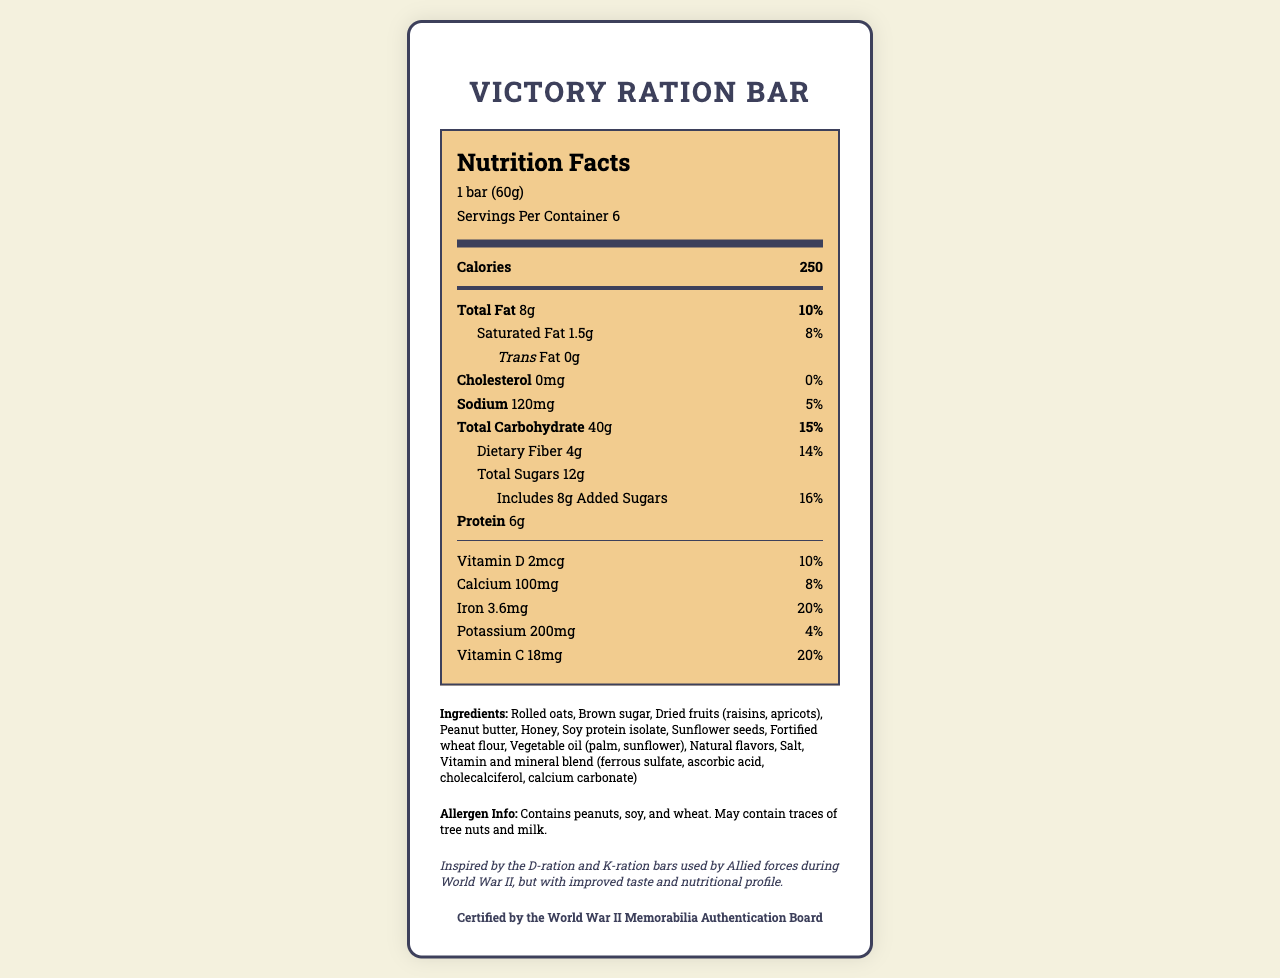what is the serving size for the Victory Ration Bar? The serving size is clearly stated as "1 bar (60g)" in the Nutrition Facts section.
Answer: 1 bar (60g) how many calories are there per serving? The number of calories per serving is listed as 250.
Answer: 250 what is the total fat content per serving in grams? The total fat content per serving is indicated as 8g.
Answer: 8g how many servings are there per container? According to the document, there are 6 servings per container.
Answer: 6 what is the amount of added sugars in one serving? The Nutrition Facts section lists added sugars as 8g per serving.
Answer: 8g what percentage of the daily value of iron does one bar provide? The amount of iron per serving is 3.6mg, which corresponds to 20% of the daily value.
Answer: 20% does the product contain any peanuts? The allergen info section specifies that the product contains peanuts.
Answer: Yes which ingredient is listed first in the ingredients list? The first ingredient listed is "Rolled oats."
Answer: Rolled oats what vitamins and minerals are included in the vitamin and mineral blend? These are listed as part of the ingredients: "Vitamin and mineral blend (ferrous sulfate, ascorbic acid, cholecalciferol, calcium carbonate)."
Answer: Ferrous sulfate, ascorbic acid, cholecalciferol, calcium carbonate how long is the shelf life of the Victory Ration Bar? The document states that the shelf life is 24 months when stored in a cool, dry place.
Answer: 24 months is there any cholesterol in the Victory Ration Bar? The cholesterol content is listed as 0mg, which means there is no cholesterol in the bar.
Answer: No does the product have a certification? The document notes that the product is "Certified by the World War II Memorabilia Authentication Board."
Answer: Yes what is the historical inspiration behind the Victory Ration Bar? The historical note section states this inspiration.
Answer: D-ration and K-ration bars used by Allied forces during World War II what is the amount of sodium per serving? The sodium content per serving is 120mg.
Answer: 120mg what is the protein content per serving? The protein content is listed as 6g per serving.
Answer: 6g which ingredient is high in protein and likely added to boost this nutrient? A. Honey B. Vitamin and mineral blend C. Soy protein isolate The ingredient list includes "Soy protein isolate," which is known to be a high-protein ingredient.
Answer: C. Soy protein isolate what amount of dietary fiber does one bar provide? The dietary fiber content per serving is 4g.
Answer: 4g which vitamin is present in the highest daily value percentage in one bar? A. Vitamin D B. Calcium C. Vitamin C Vitamin C is present at 20% of the daily value, which is higher than the daily values for Vitamin D (10%) and Calcium (8%).
Answer: C. Vitamin C does the Victory Ration Bar contain any tree nuts? The allergen info section indicates that the bar may contain traces of tree nuts.
Answer: May contain traces briefly describe the main idea of the document The document includes detailed information about serving size, calories, fats, vitamins, and minerals for the bar, along with historical inspiration and allergen information.
Answer: The document provides nutrition facts, ingredient information, and historical context for the Victory Ration Bar, a modern commemorative food product inspired by World War II rations with improved nutritional value. is the product's packaging related to its historical inspiration? The packaging is described as "moisture-resistant, olive drab packaging inspired by World War II K-rations," linking it to its historical theme.
Answer: Yes how many grams of trans fat are there per serving? The trans fat content per serving is listed as 0g.
Answer: 0g who is the manufacturer of the Victory Ration Bar? The manufacturer is listed as Patriot Provisions, Inc.
Answer: Patriot Provisions, Inc. what improved aspect does the Victory Ration Bar have compared to the original World War II rations? According to the historical note, the bar has improved taste and nutritional profile compared to the original rations.
Answer: Improved taste and nutritional profile In which country is the Victory Ration Bar manufactured? The document does not specify the manufacturing country.
Answer: Not enough information 